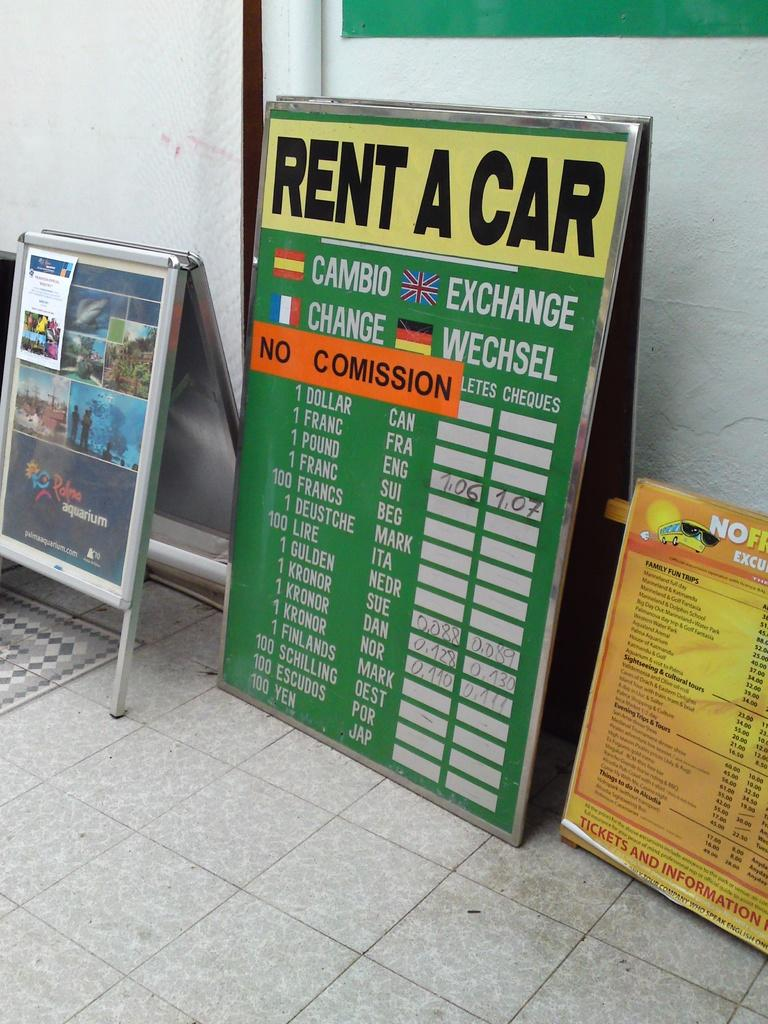Provide a one-sentence caption for the provided image. A large green rent a car sign is propped up against a wall between two other signs. 